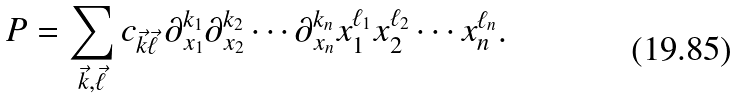<formula> <loc_0><loc_0><loc_500><loc_500>P = \sum _ { { \vec { k } } , { \vec { \ell } } } c _ { { \vec { k } } { \vec { \ell } } } \, \partial _ { x _ { 1 } } ^ { k _ { 1 } } \partial _ { x _ { 2 } } ^ { k _ { 2 } } \cdots \partial _ { x _ { n } } ^ { k _ { n } } x _ { 1 } ^ { \ell _ { 1 } } x _ { 2 } ^ { \ell _ { 2 } } \cdots x _ { n } ^ { \ell _ { n } } .</formula> 